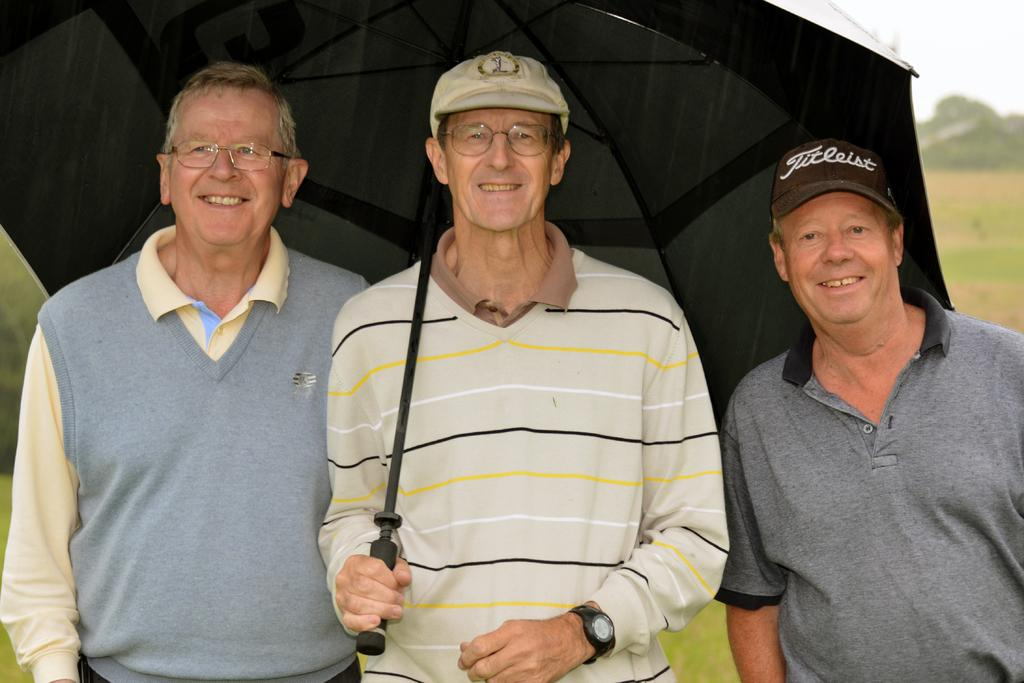How many people are in the image? There are three men in the image. What are the men doing in the image? The men are standing and laughing. What is the middle person holding in the image? The middle person is holding an umbrella over all of them. What can be seen in the background of the image? There is grass, trees, and the sky visible in the background of the image. What type of writing system is visible on the umbrella in the image? There is no writing system visible on the umbrella in the image. Can you touch the trees in the background of the image? The trees in the background of the image are not within reach, so they cannot be touched. 